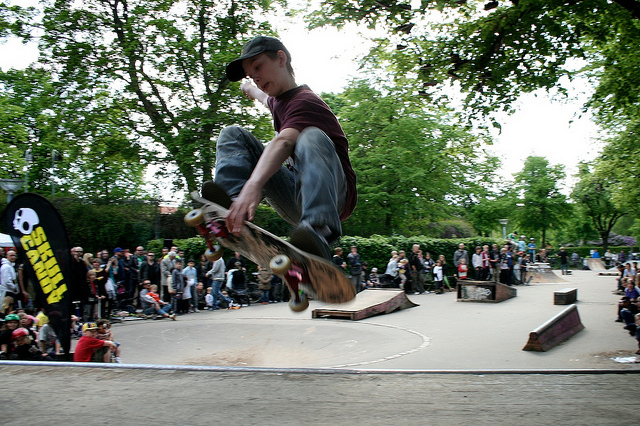<image>What is the name of this skate park? I don't know the exact name of this skate park. It might be Skullcandy, Skullcano, Skateland, Central Park or Town Park. What is the name of this skate park? I don't know the name of this skate park. It can be 'unknown', 'skullcandy', 'central park', 'skateland', 'skullcano', or 'town park'. 